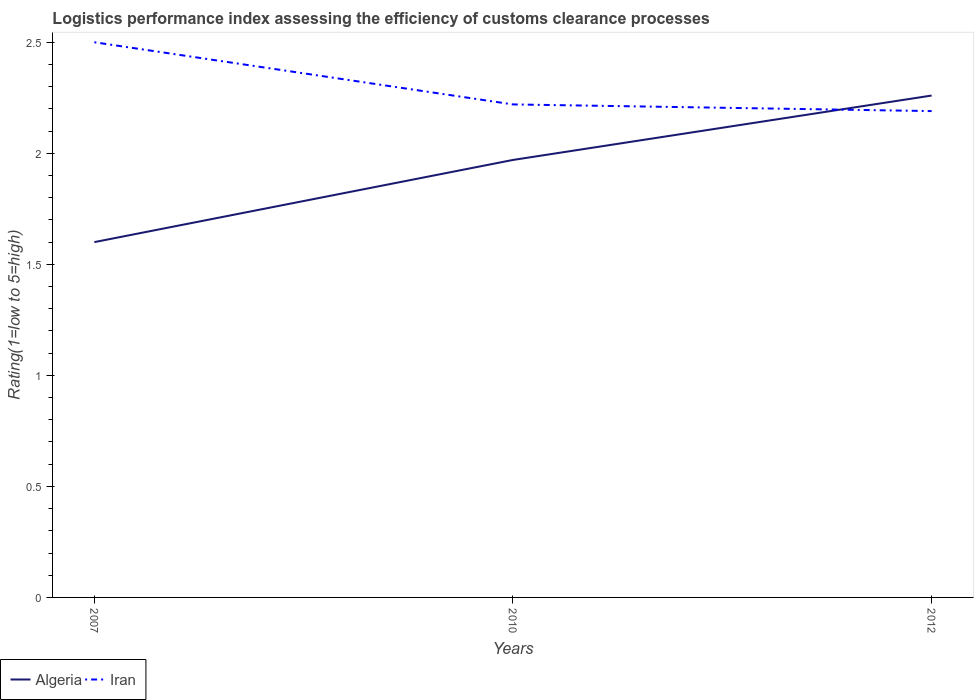Does the line corresponding to Algeria intersect with the line corresponding to Iran?
Your answer should be very brief. Yes. Is the number of lines equal to the number of legend labels?
Your response must be concise. Yes. Across all years, what is the maximum Logistic performance index in Iran?
Your answer should be compact. 2.19. In which year was the Logistic performance index in Iran maximum?
Offer a very short reply. 2012. What is the total Logistic performance index in Algeria in the graph?
Provide a short and direct response. -0.29. What is the difference between the highest and the second highest Logistic performance index in Algeria?
Provide a short and direct response. 0.66. What is the difference between the highest and the lowest Logistic performance index in Iran?
Make the answer very short. 1. Is the Logistic performance index in Algeria strictly greater than the Logistic performance index in Iran over the years?
Ensure brevity in your answer.  No. How many lines are there?
Offer a very short reply. 2. How many years are there in the graph?
Make the answer very short. 3. What is the difference between two consecutive major ticks on the Y-axis?
Provide a short and direct response. 0.5. Does the graph contain any zero values?
Ensure brevity in your answer.  No. Does the graph contain grids?
Your response must be concise. No. Where does the legend appear in the graph?
Your answer should be compact. Bottom left. What is the title of the graph?
Ensure brevity in your answer.  Logistics performance index assessing the efficiency of customs clearance processes. Does "Sub-Saharan Africa (developing only)" appear as one of the legend labels in the graph?
Your answer should be very brief. No. What is the label or title of the X-axis?
Your response must be concise. Years. What is the label or title of the Y-axis?
Provide a succinct answer. Rating(1=low to 5=high). What is the Rating(1=low to 5=high) in Iran in 2007?
Your answer should be very brief. 2.5. What is the Rating(1=low to 5=high) of Algeria in 2010?
Make the answer very short. 1.97. What is the Rating(1=low to 5=high) of Iran in 2010?
Your answer should be compact. 2.22. What is the Rating(1=low to 5=high) in Algeria in 2012?
Provide a succinct answer. 2.26. What is the Rating(1=low to 5=high) in Iran in 2012?
Provide a short and direct response. 2.19. Across all years, what is the maximum Rating(1=low to 5=high) of Algeria?
Ensure brevity in your answer.  2.26. Across all years, what is the maximum Rating(1=low to 5=high) in Iran?
Your answer should be very brief. 2.5. Across all years, what is the minimum Rating(1=low to 5=high) in Algeria?
Make the answer very short. 1.6. Across all years, what is the minimum Rating(1=low to 5=high) of Iran?
Your answer should be compact. 2.19. What is the total Rating(1=low to 5=high) in Algeria in the graph?
Give a very brief answer. 5.83. What is the total Rating(1=low to 5=high) in Iran in the graph?
Provide a succinct answer. 6.91. What is the difference between the Rating(1=low to 5=high) of Algeria in 2007 and that in 2010?
Keep it short and to the point. -0.37. What is the difference between the Rating(1=low to 5=high) of Iran in 2007 and that in 2010?
Offer a terse response. 0.28. What is the difference between the Rating(1=low to 5=high) in Algeria in 2007 and that in 2012?
Give a very brief answer. -0.66. What is the difference between the Rating(1=low to 5=high) of Iran in 2007 and that in 2012?
Your answer should be compact. 0.31. What is the difference between the Rating(1=low to 5=high) of Algeria in 2010 and that in 2012?
Make the answer very short. -0.29. What is the difference between the Rating(1=low to 5=high) of Algeria in 2007 and the Rating(1=low to 5=high) of Iran in 2010?
Offer a terse response. -0.62. What is the difference between the Rating(1=low to 5=high) of Algeria in 2007 and the Rating(1=low to 5=high) of Iran in 2012?
Ensure brevity in your answer.  -0.59. What is the difference between the Rating(1=low to 5=high) in Algeria in 2010 and the Rating(1=low to 5=high) in Iran in 2012?
Provide a short and direct response. -0.22. What is the average Rating(1=low to 5=high) of Algeria per year?
Offer a terse response. 1.94. What is the average Rating(1=low to 5=high) in Iran per year?
Provide a succinct answer. 2.3. In the year 2007, what is the difference between the Rating(1=low to 5=high) of Algeria and Rating(1=low to 5=high) of Iran?
Make the answer very short. -0.9. In the year 2010, what is the difference between the Rating(1=low to 5=high) of Algeria and Rating(1=low to 5=high) of Iran?
Offer a terse response. -0.25. In the year 2012, what is the difference between the Rating(1=low to 5=high) of Algeria and Rating(1=low to 5=high) of Iran?
Make the answer very short. 0.07. What is the ratio of the Rating(1=low to 5=high) in Algeria in 2007 to that in 2010?
Your response must be concise. 0.81. What is the ratio of the Rating(1=low to 5=high) of Iran in 2007 to that in 2010?
Give a very brief answer. 1.13. What is the ratio of the Rating(1=low to 5=high) in Algeria in 2007 to that in 2012?
Ensure brevity in your answer.  0.71. What is the ratio of the Rating(1=low to 5=high) of Iran in 2007 to that in 2012?
Keep it short and to the point. 1.14. What is the ratio of the Rating(1=low to 5=high) in Algeria in 2010 to that in 2012?
Ensure brevity in your answer.  0.87. What is the ratio of the Rating(1=low to 5=high) in Iran in 2010 to that in 2012?
Keep it short and to the point. 1.01. What is the difference between the highest and the second highest Rating(1=low to 5=high) of Algeria?
Give a very brief answer. 0.29. What is the difference between the highest and the second highest Rating(1=low to 5=high) of Iran?
Your answer should be compact. 0.28. What is the difference between the highest and the lowest Rating(1=low to 5=high) in Algeria?
Provide a succinct answer. 0.66. What is the difference between the highest and the lowest Rating(1=low to 5=high) of Iran?
Provide a short and direct response. 0.31. 